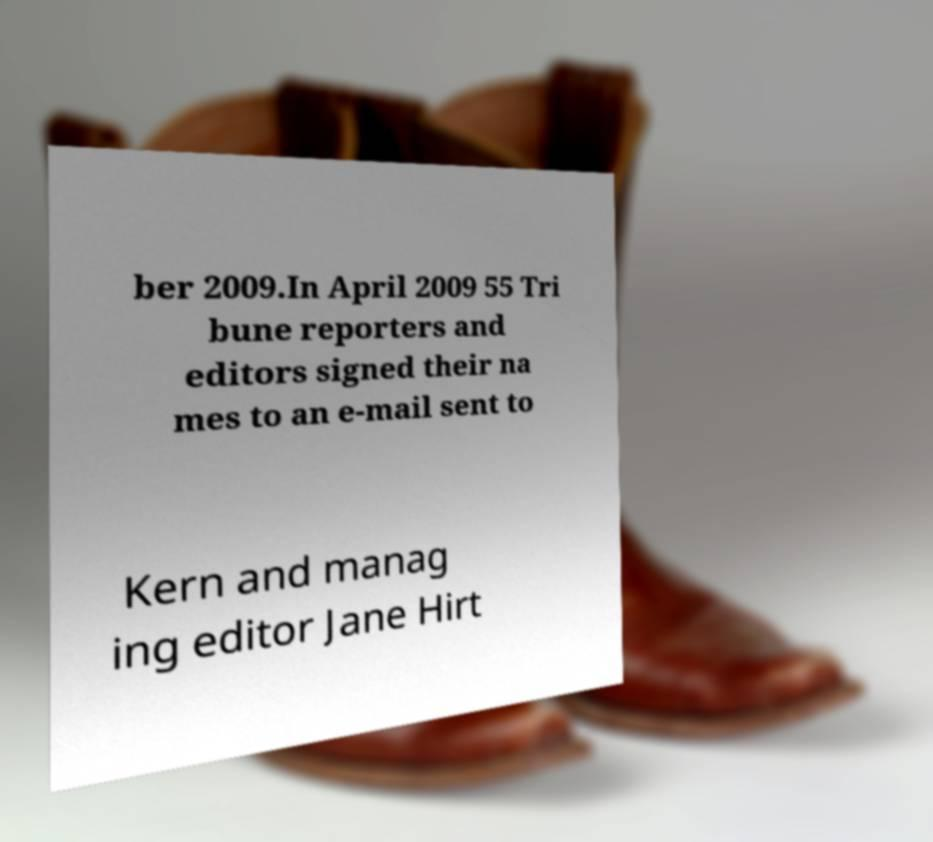Can you accurately transcribe the text from the provided image for me? ber 2009.In April 2009 55 Tri bune reporters and editors signed their na mes to an e-mail sent to Kern and manag ing editor Jane Hirt 